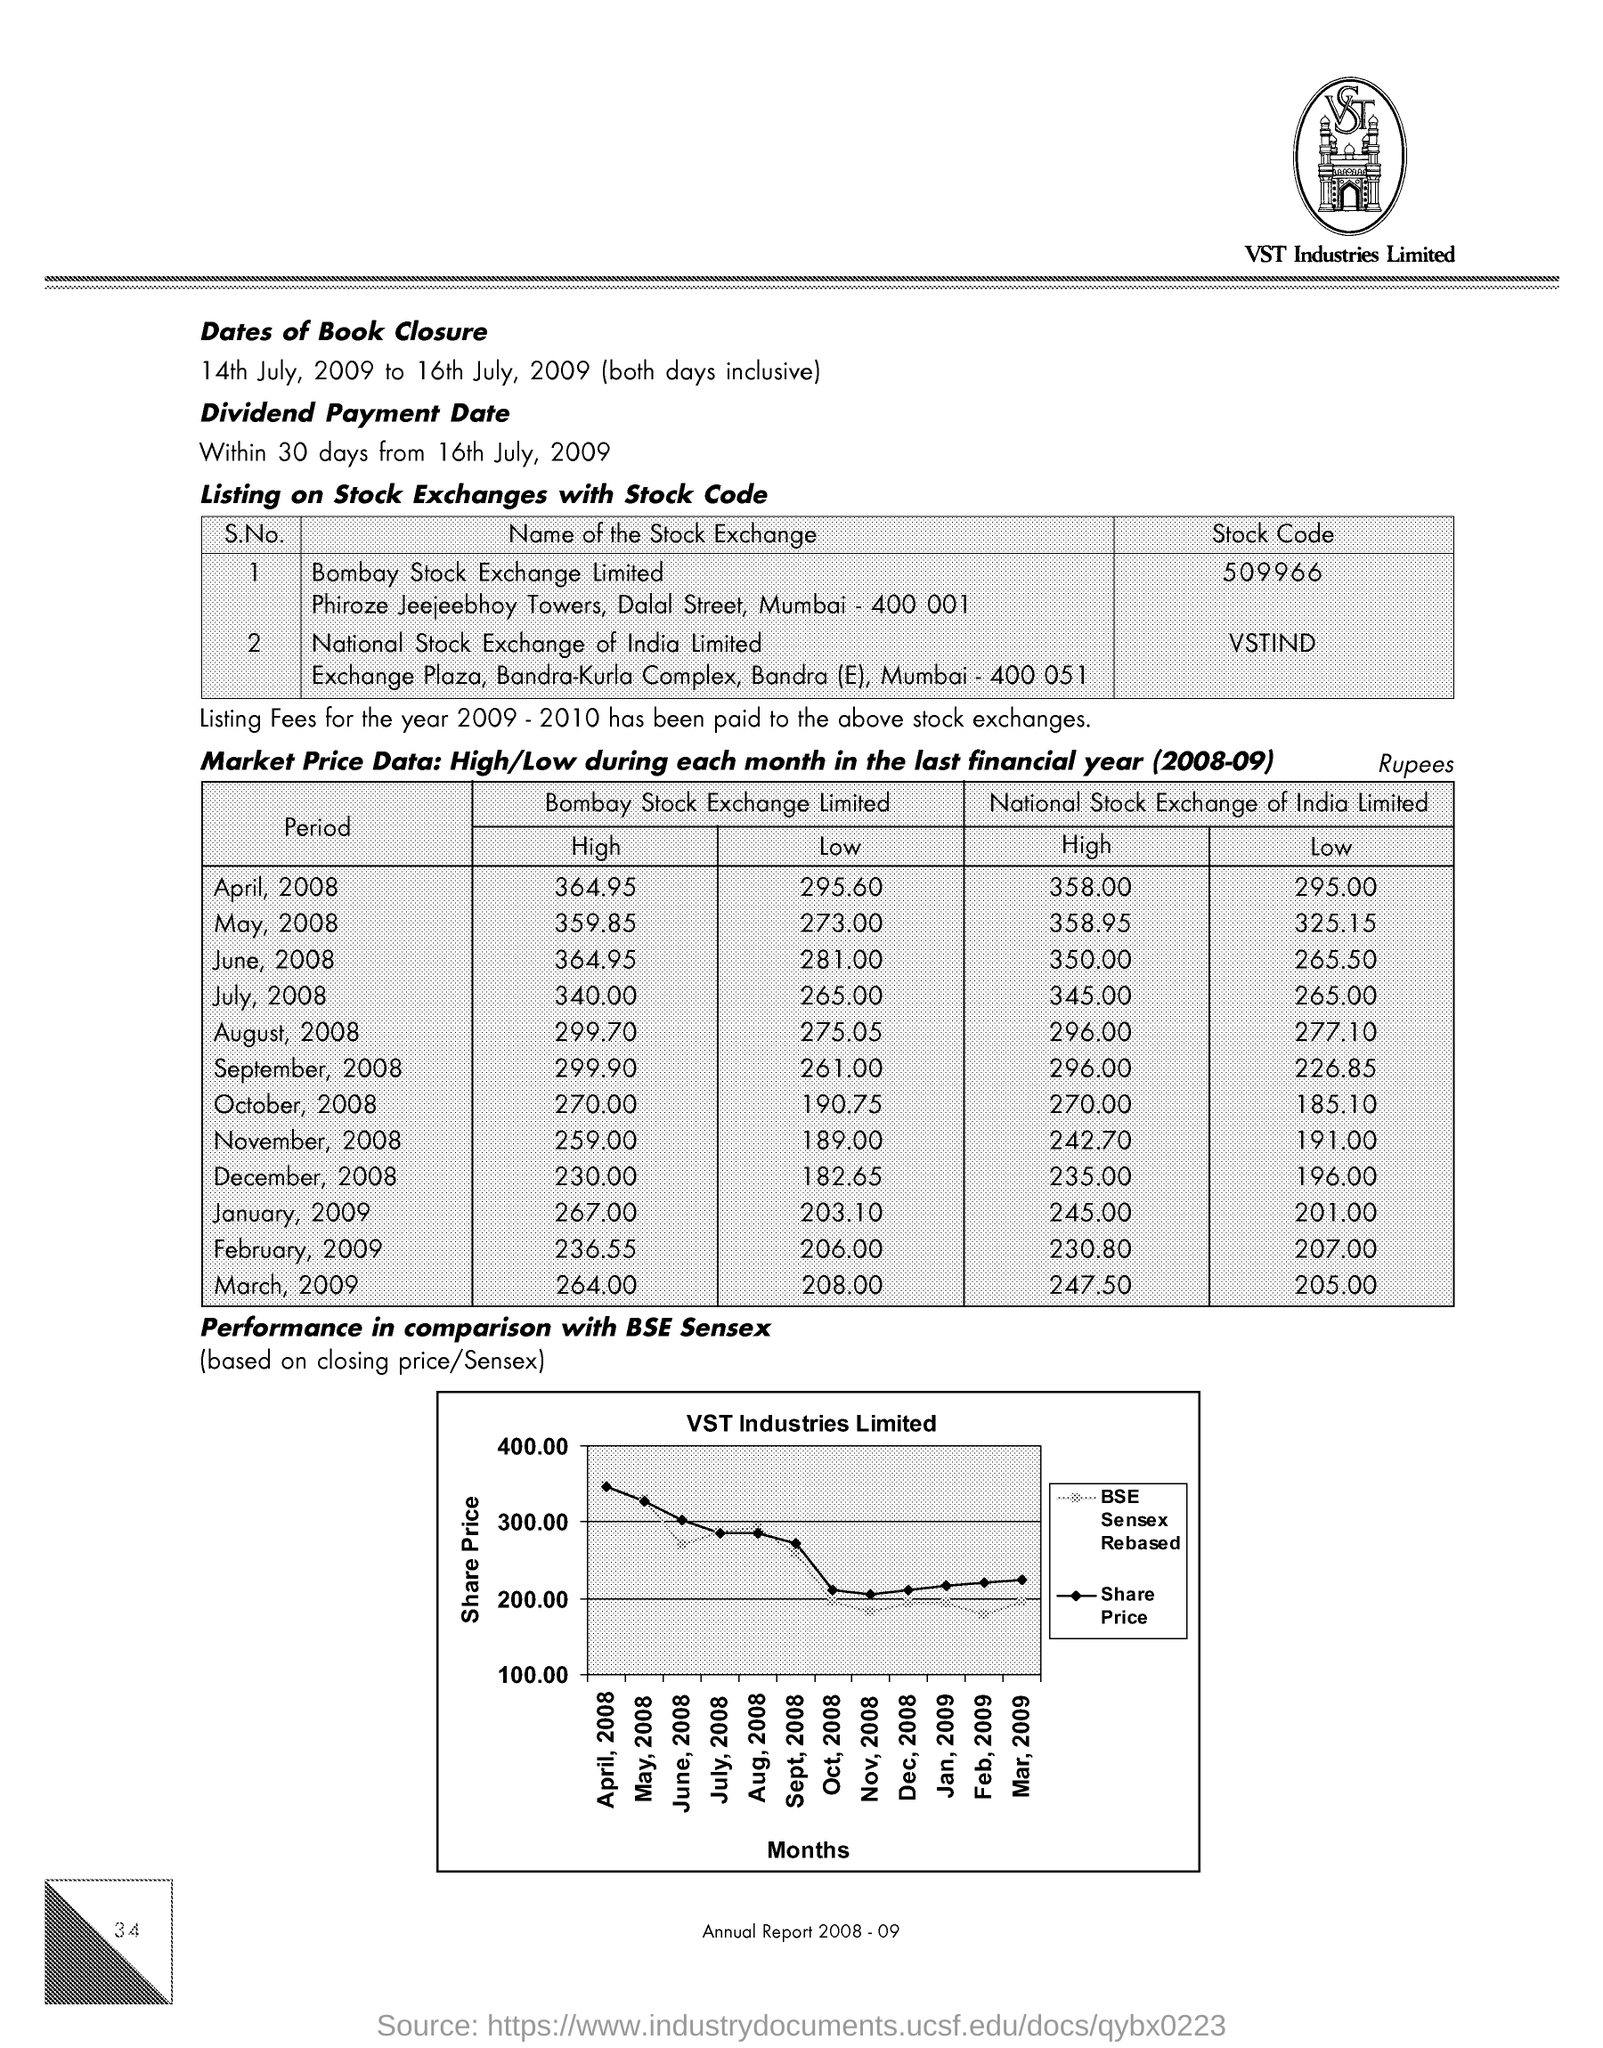What is the Stock Code of company's shares listed on Bombay Stock Exchange Limited?
Offer a terse response. 509966. What is the Stock Code of company's shares listed on National Stock Exchange of India Limited ?
Keep it short and to the point. VSTIND. What does the Y-axis of the graph describing the performance in comparison with BSE Sensex represent?
Offer a very short reply. SHARE PRICE. What does the X-axis of the graph describing the performance in comparison with BSE Sensex represent?
Keep it short and to the point. Months. What is the highest Market share price(Rs.) on Bombay Stock Exchange in April 2008 for the financial year 2008-09?
Offer a terse response. 364.95. What is the highest Market share price(Rs.) on Bombay Stock Exchange in March 2009 for the financial year 2008-09?
Keep it short and to the point. 264.00. Which company is mentioned in the header of the document?
Provide a short and direct response. VST Industries Limited. 